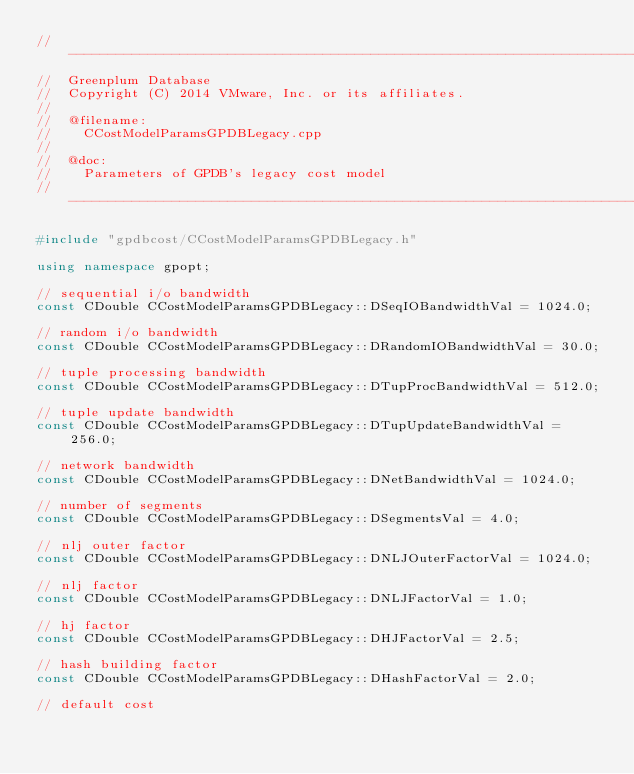<code> <loc_0><loc_0><loc_500><loc_500><_C++_>//---------------------------------------------------------------------------
//	Greenplum Database
//	Copyright (C) 2014 VMware, Inc. or its affiliates.
//
//	@filename:
//		CCostModelParamsGPDBLegacy.cpp
//
//	@doc:
//		Parameters of GPDB's legacy cost model
//---------------------------------------------------------------------------

#include "gpdbcost/CCostModelParamsGPDBLegacy.h"

using namespace gpopt;

// sequential i/o bandwidth
const CDouble CCostModelParamsGPDBLegacy::DSeqIOBandwidthVal = 1024.0;

// random i/o bandwidth
const CDouble CCostModelParamsGPDBLegacy::DRandomIOBandwidthVal = 30.0;

// tuple processing bandwidth
const CDouble CCostModelParamsGPDBLegacy::DTupProcBandwidthVal = 512.0;

// tuple update bandwidth
const CDouble CCostModelParamsGPDBLegacy::DTupUpdateBandwidthVal = 256.0;

// network bandwidth
const CDouble CCostModelParamsGPDBLegacy::DNetBandwidthVal = 1024.0;

// number of segments
const CDouble CCostModelParamsGPDBLegacy::DSegmentsVal = 4.0;

// nlj outer factor
const CDouble CCostModelParamsGPDBLegacy::DNLJOuterFactorVal = 1024.0;

// nlj factor
const CDouble CCostModelParamsGPDBLegacy::DNLJFactorVal = 1.0;

// hj factor
const CDouble CCostModelParamsGPDBLegacy::DHJFactorVal = 2.5;

// hash building factor
const CDouble CCostModelParamsGPDBLegacy::DHashFactorVal = 2.0;

// default cost</code> 